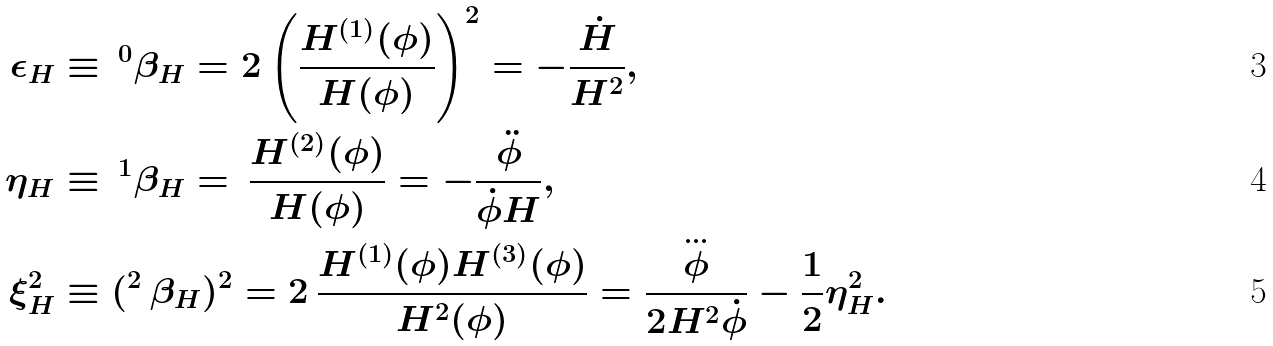Convert formula to latex. <formula><loc_0><loc_0><loc_500><loc_500>\epsilon _ { H } & \equiv \, ^ { 0 } \beta _ { H } = 2 \left ( \frac { H ^ { ( 1 ) } ( \phi ) } { H ( \phi ) } \right ) ^ { 2 } = - \frac { \dot { H } } { H ^ { 2 } } , \\ \eta _ { H } & \equiv \, ^ { 1 } \beta _ { H } = \, \frac { H ^ { ( 2 ) } ( \phi ) } { H ( \phi ) } = - \frac { \ddot { \phi } } { \dot { \phi } H } , \\ \xi ^ { 2 } _ { H } & \equiv ( ^ { 2 } \, \beta _ { H } ) ^ { 2 } = 2 \, \frac { H ^ { ( 1 ) } ( \phi ) H ^ { ( 3 ) } ( \phi ) } { H ^ { 2 } ( \phi ) } = \frac { \stackrel { \dots } { \phi } } { 2 H ^ { 2 } \dot { \phi } } - \frac { 1 } { 2 } \eta _ { H } ^ { 2 } .</formula> 